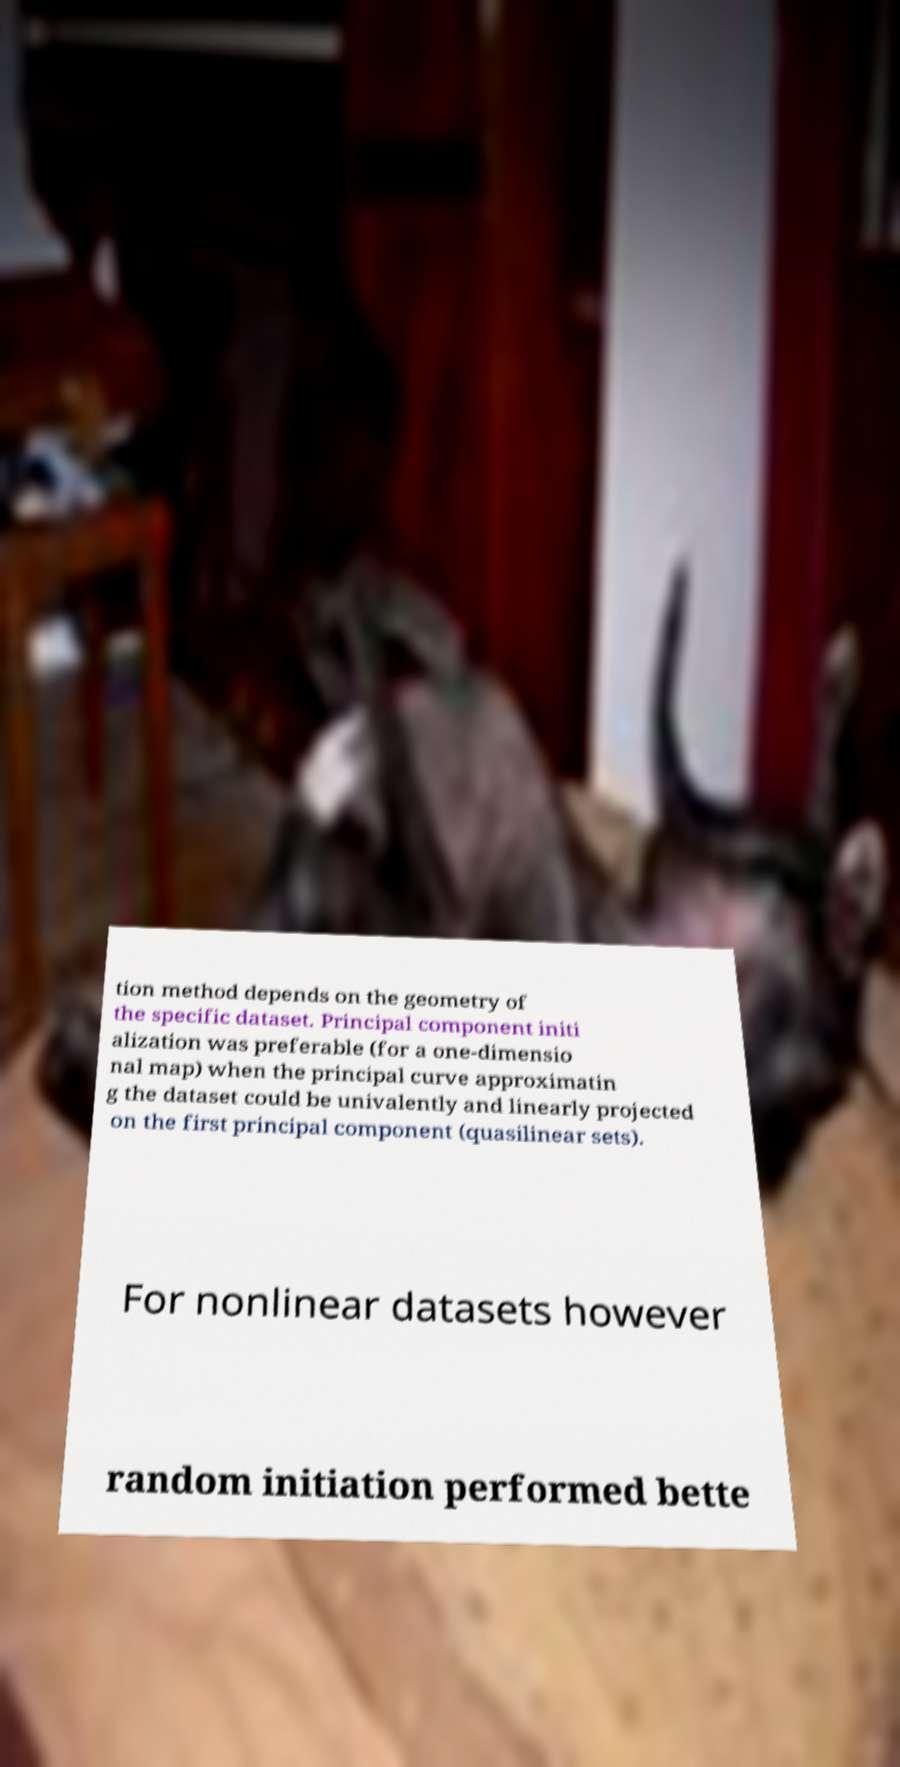What messages or text are displayed in this image? I need them in a readable, typed format. tion method depends on the geometry of the specific dataset. Principal component initi alization was preferable (for a one-dimensio nal map) when the principal curve approximatin g the dataset could be univalently and linearly projected on the first principal component (quasilinear sets). For nonlinear datasets however random initiation performed bette 